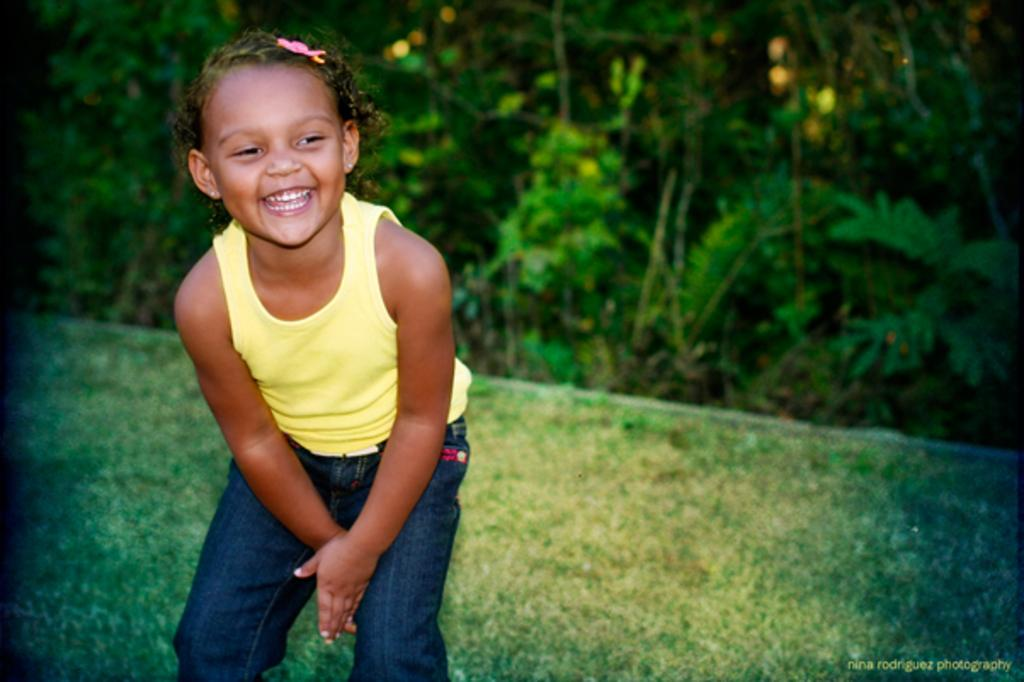Who is present in the image? There is a girl in the image. What is the girl's expression in the image? The girl is smiling in the image. What type of natural environment is visible in the image? There is grass visible in the image, and trees are in the background. Is there any text or marking in the image? Yes, there is a watermark in the bottom right corner of the image. How many jellyfish can be seen swimming in the grass in the image? There are no jellyfish present in the image, and jellyfish cannot swim in grass. Can you describe the girl's ability to jump in the image? The image does not show the girl jumping, so we cannot describe her ability to jump based on the image. 